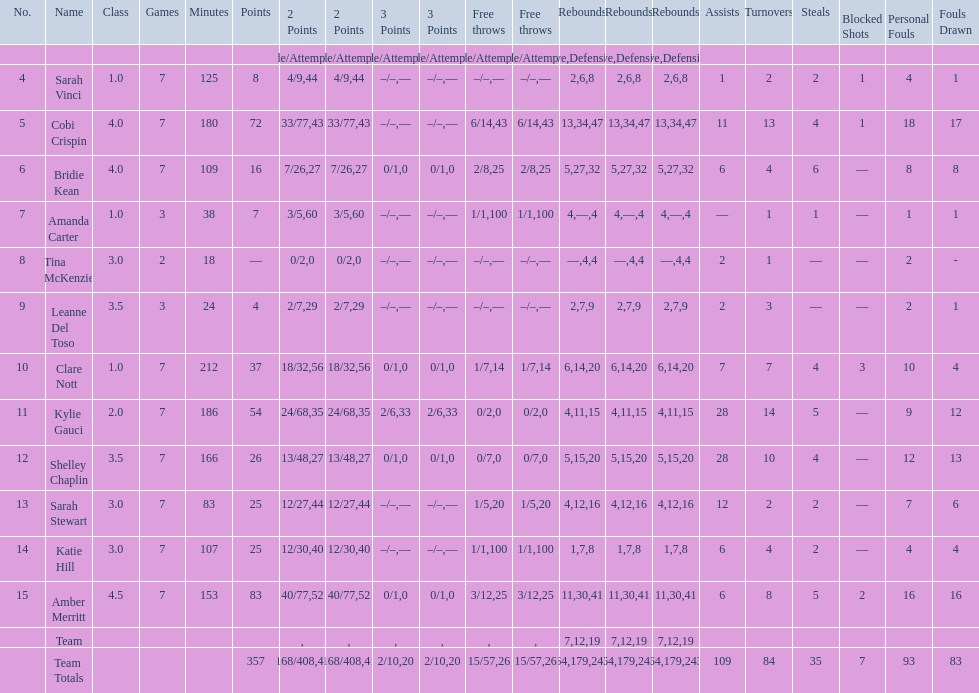After completing seven games, how many players managed to score above 30 points? 4. 